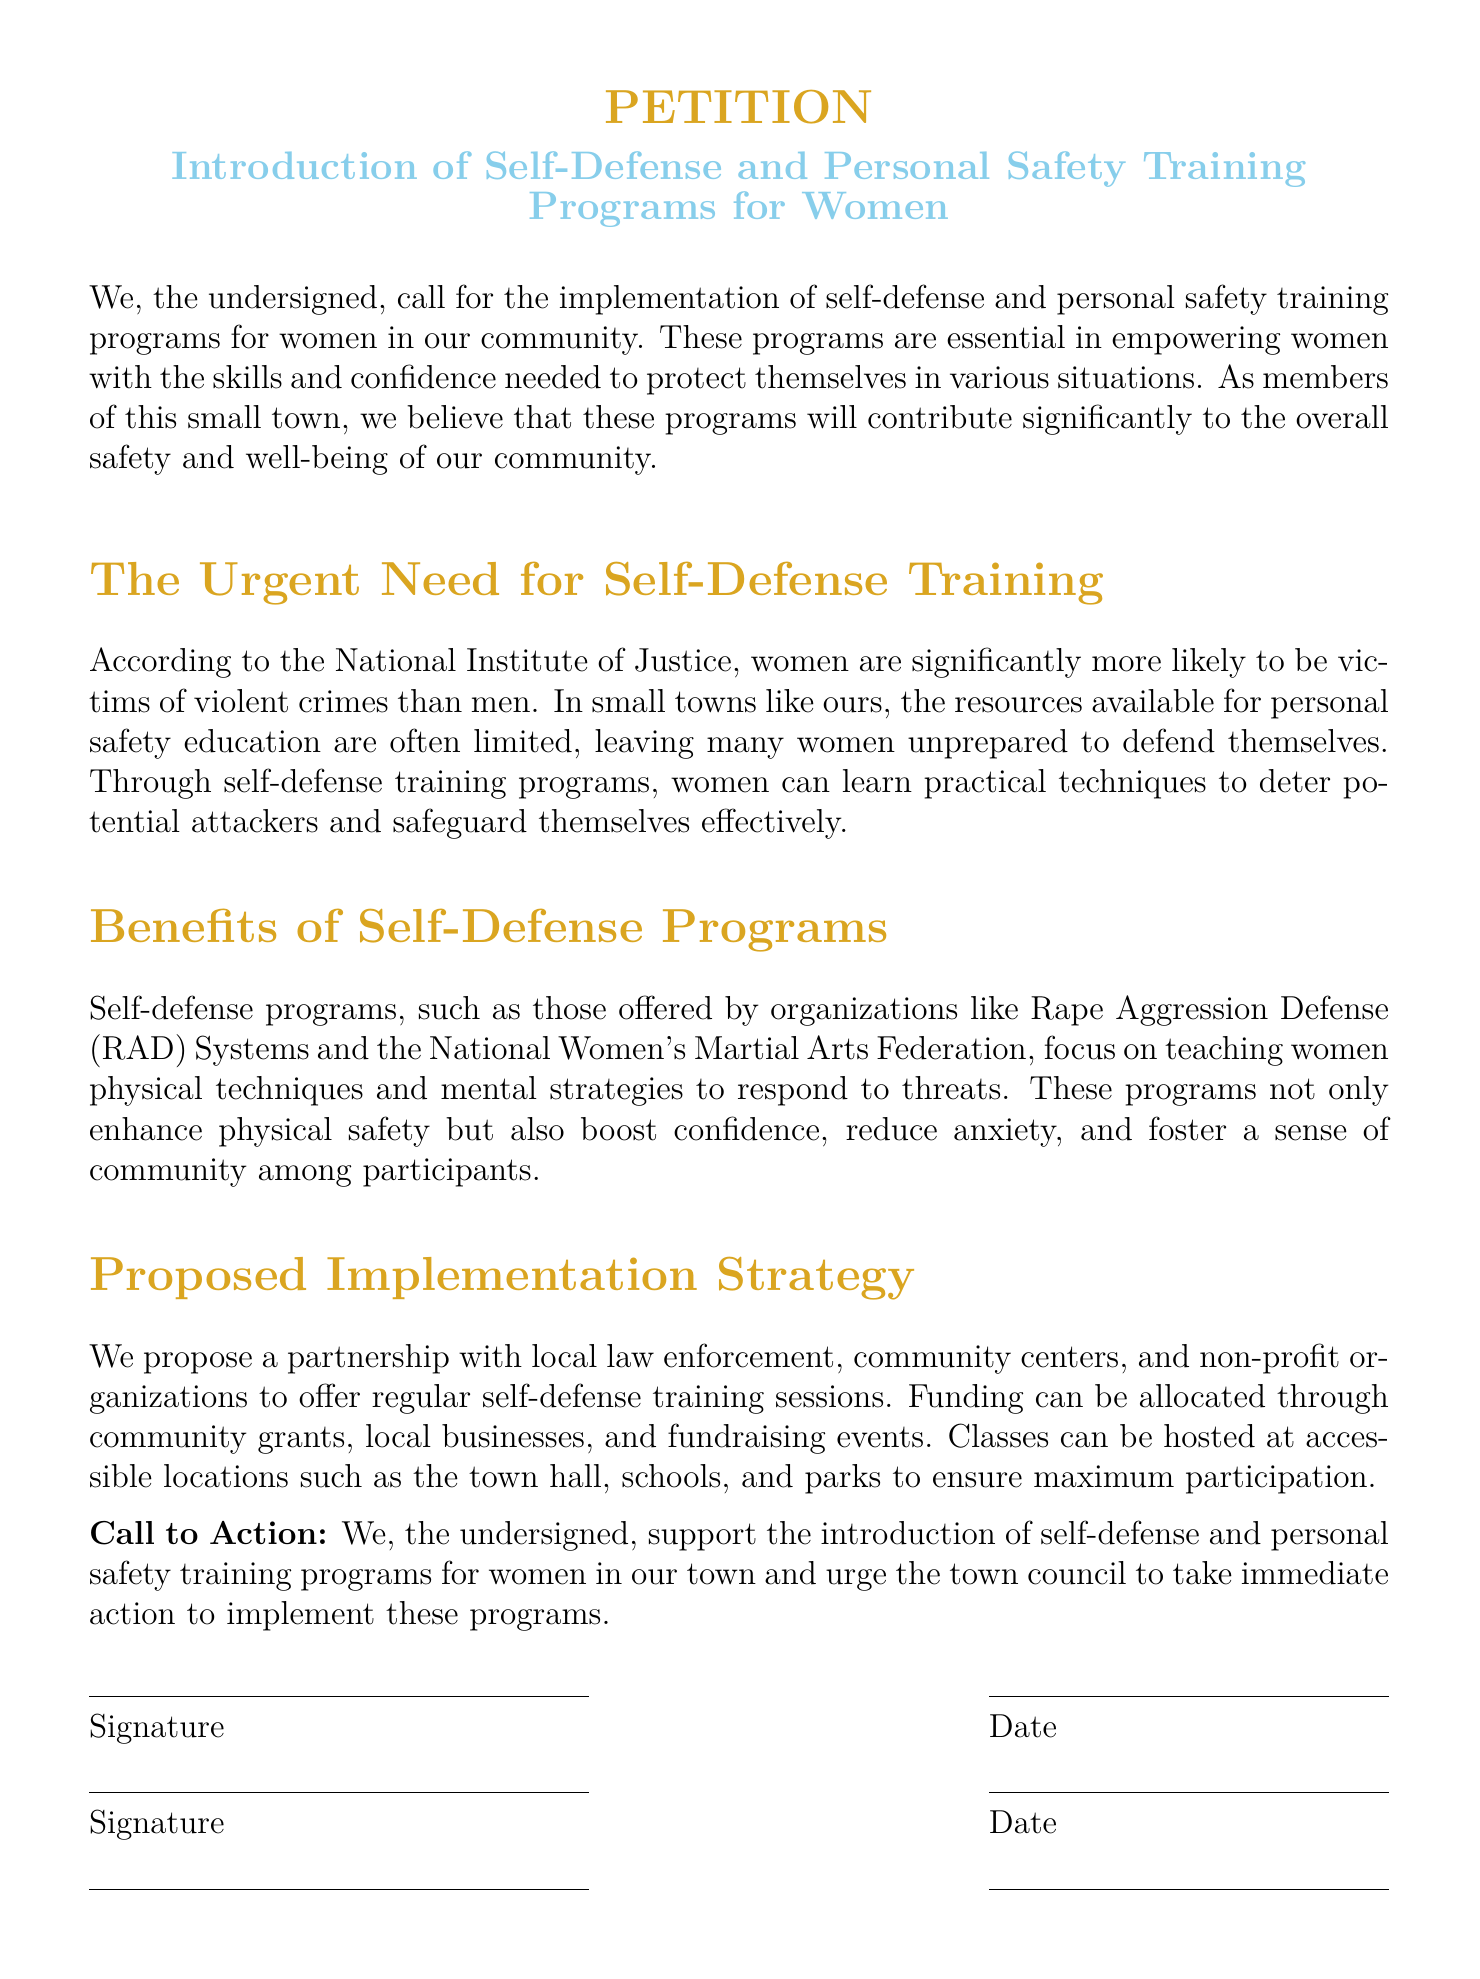What is the title of the petition? The title of the petition is centered and highlighted in the document, indicating the subject matter of the petition.
Answer: Introduction of Self-Defense and Personal Safety Training Programs for Women Who are the targeted beneficiaries of the training programs? The text specifies that the training programs are aimed at empowering a specific group within the community for their safety.
Answer: Women What is the proposed partnership for implementing the self-defense programs? The document discusses a collaborative effort involving several local entities to implement the programs.
Answer: Local law enforcement, community centers, and non-profit organizations What organization is mentioned as offering self-defense programs? The text provides examples of organizations that focus on women's self-defense training, serving as a reference point for the proposed programs.
Answer: Rape Aggression Defense (RAD) Systems What is one expected benefit of the self-defense programs? The document highlights various advantages of participating in these programs that extend beyond physical safety.
Answer: Boost confidence What funding sources are suggested for the training programs? The petition outlines various ways to finance the implementation of the training programs, indicating community involvement.
Answer: Community grants, local businesses, and fundraising events What is the call to action in the petition? The final section of the document invites a specific group to take action regarding the proposed training programs.
Answer: Urge the town council to take immediate action to implement these programs What is the primary concern addressed by the petition? The text discusses a significant issue that affects a specific demographic in the community and emphasizes the need for readiness and skills.
Answer: Personal safety and self-defense for women 